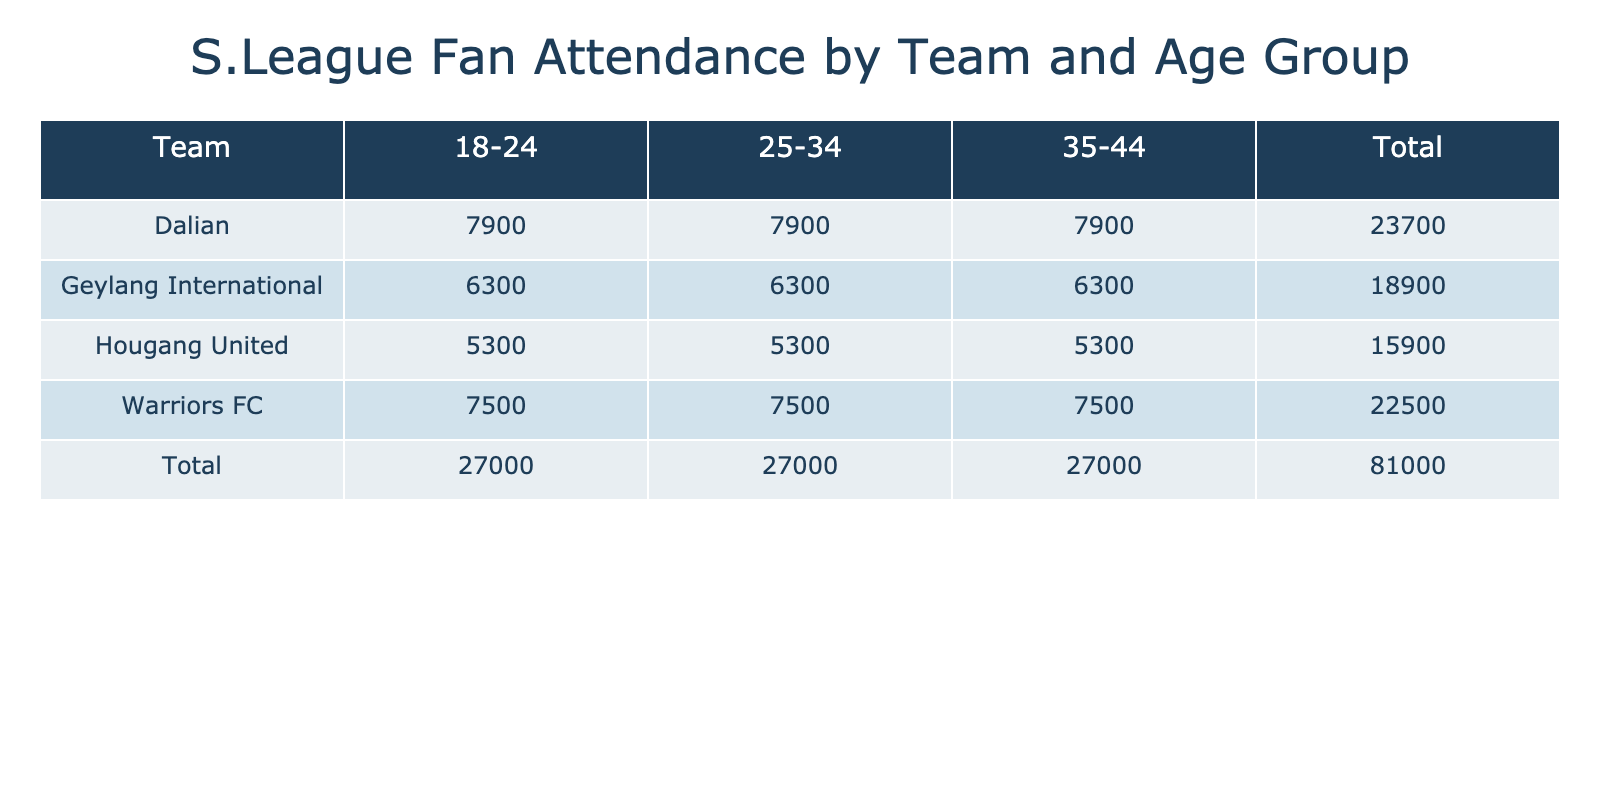What was the total attendance for Warriors FC on February 12, 2023? The attendance for Warriors FC on February 12, 2023, was recorded for three age groups: 3500 for 18-24, 3500 for 25-34, and 3500 for 35-44. Adding these together gives us: 3500 + 3500 + 3500 = 10500.
Answer: 10500 Which age group had the highest attendance for Dalian on February 12, 2023? For Dalian on February 12, 2023, the attendance figures for each age group were 4200 for 18-24, 4200 for 25-34, and 4200 for 35-44. All age groups had the same attendance, hence none had a higher attendance than others.
Answer: All are equal Did Geylang International have a higher total attendance than Hougang United on February 19, 2023? Geylang International's attendance on February 19, 2023 consisted of 3300 for each of the three age groups, resulting in a total of: 3300 + 3300 + 3300 = 9900. Hougang United's attendance on the same date was 2800 for each age group, resulting in: 2800 + 2800 + 2800 = 8400. Comparing the totals: 9900 (Geylang) > 8400 (Hougang).
Answer: Yes What is the average attendance for Warriors FC across both match days? Warriors FC had total attendances of 10500 on February 12, 2023, and 12000 on February 19, 2023. The average is calculated by summing both totals and dividing by the number of match days: (10500 + 12000) / 2 = 22500 / 2 = 11250.
Answer: 11250 Was the total attendance for Hougang United on February 12, 2023, more than that for Geylang International on the same day? The total attendance for Hougang United on February 12, 2023, was 2500 for each age group, totaling: 2500 + 2500 + 2500 = 7500. For Geylang International the total was 3000 for each age group, summing up to: 3000 + 3000 + 3000 = 9000. Comparing the two totals: 7500 (Hougang) < 9000 (Geylang).
Answer: No Which team had the lowest total attendance across both match days? The total attendance for each team was summarized: Warriors FC: 10500 (Feb 12) + 12000 (Feb 19) = 22500, Dalian: 4200 (Feb 12) + 11100 (Feb 19) = 10000, Geylang International: 6000 (Feb 12) + 9900 (Feb 19) = 12900, Hougang United: 7500 (Feb 12) + 8400 (Feb 19) = 15900. The lowest total is Dalian with 10000.
Answer: Dalian 